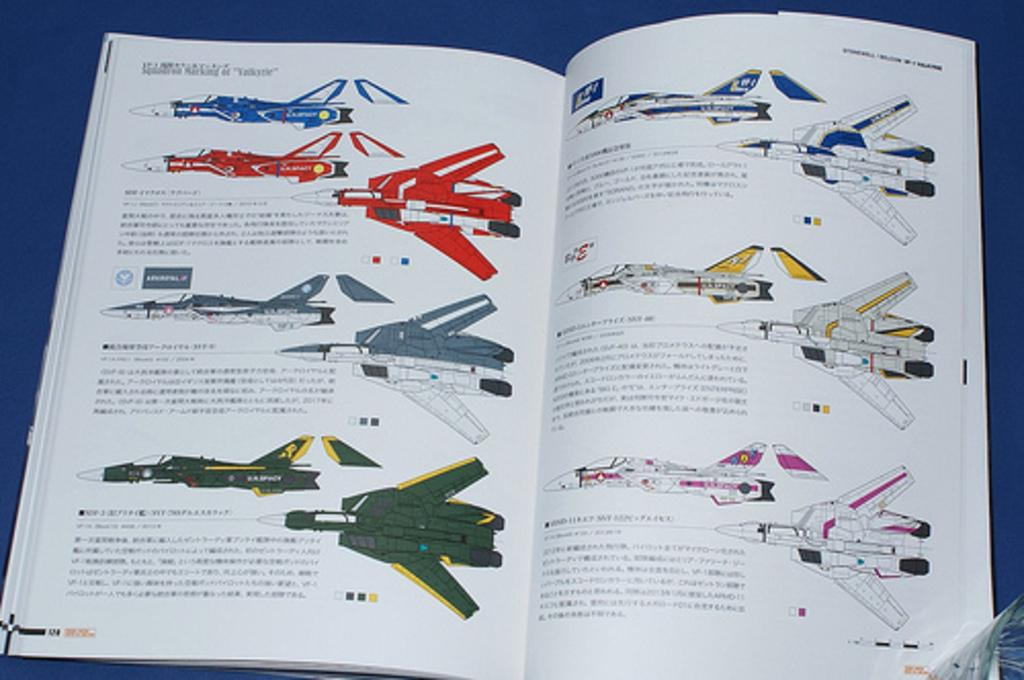What object is on the table in the image? There is a book on the table in the image. What is the content of the book? The book contains pictures of fighter jets. Is there any text in the book? Yes, there is text in the book. What type of tools does the carpenter use in the image? There is no carpenter present in the image, and therefore no tools can be observed. What time of day is depicted in the image? The image does not provide any information about the time of day. 